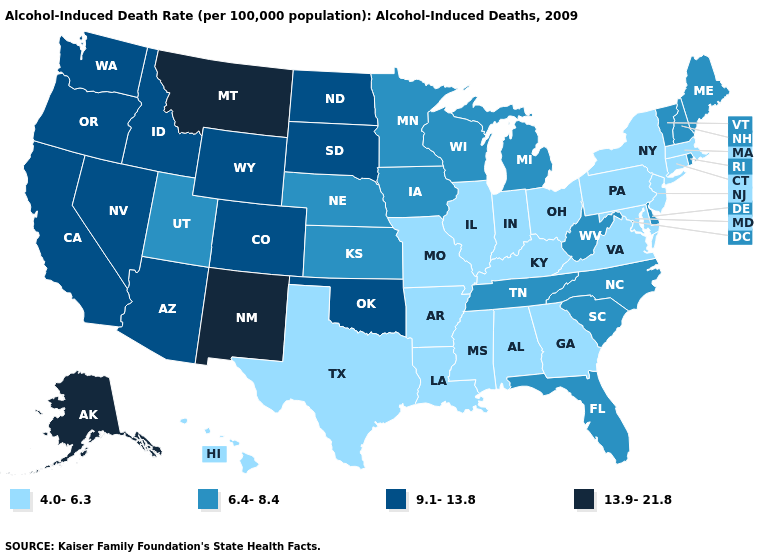What is the lowest value in the MidWest?
Write a very short answer. 4.0-6.3. Which states hav the highest value in the MidWest?
Keep it brief. North Dakota, South Dakota. Name the states that have a value in the range 13.9-21.8?
Concise answer only. Alaska, Montana, New Mexico. What is the lowest value in states that border Wisconsin?
Short answer required. 4.0-6.3. Which states have the lowest value in the USA?
Give a very brief answer. Alabama, Arkansas, Connecticut, Georgia, Hawaii, Illinois, Indiana, Kentucky, Louisiana, Maryland, Massachusetts, Mississippi, Missouri, New Jersey, New York, Ohio, Pennsylvania, Texas, Virginia. Does West Virginia have the highest value in the USA?
Write a very short answer. No. Does Mississippi have the same value as Missouri?
Write a very short answer. Yes. Does the map have missing data?
Answer briefly. No. What is the highest value in the USA?
Give a very brief answer. 13.9-21.8. What is the lowest value in the Northeast?
Answer briefly. 4.0-6.3. Which states have the highest value in the USA?
Answer briefly. Alaska, Montana, New Mexico. Name the states that have a value in the range 4.0-6.3?
Concise answer only. Alabama, Arkansas, Connecticut, Georgia, Hawaii, Illinois, Indiana, Kentucky, Louisiana, Maryland, Massachusetts, Mississippi, Missouri, New Jersey, New York, Ohio, Pennsylvania, Texas, Virginia. What is the value of Delaware?
Be succinct. 6.4-8.4. What is the value of Florida?
Keep it brief. 6.4-8.4. 